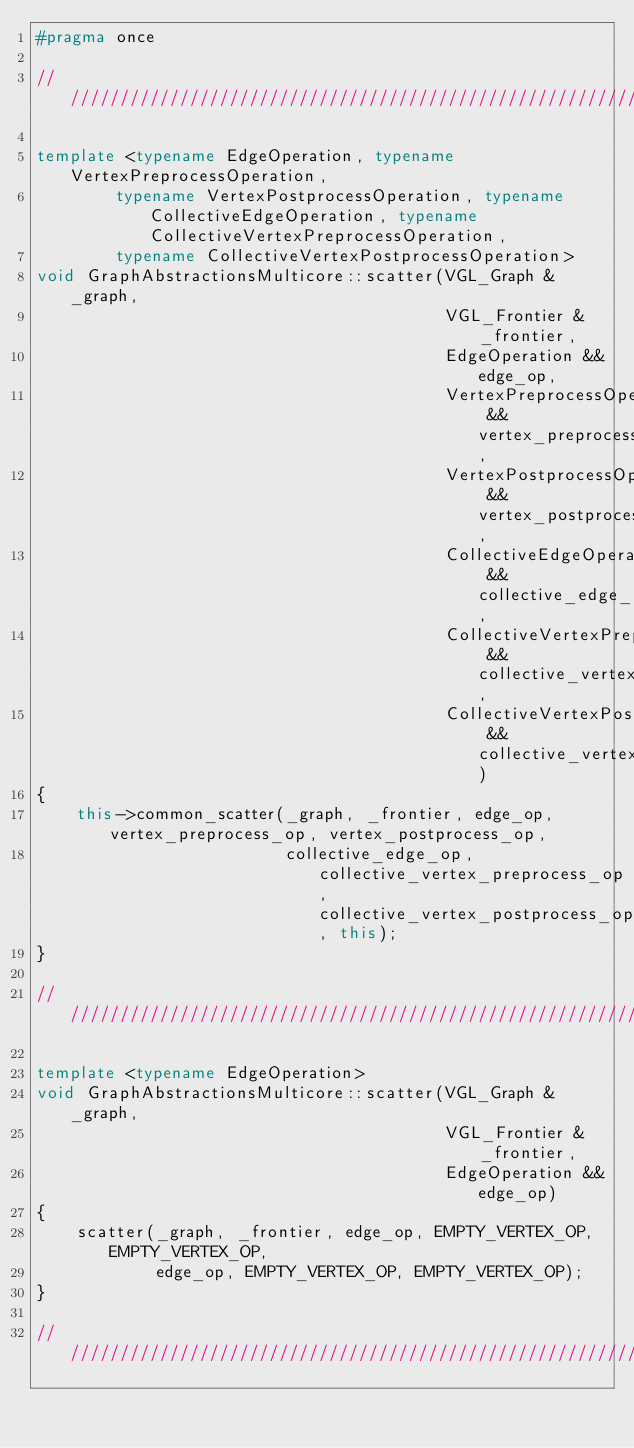Convert code to text. <code><loc_0><loc_0><loc_500><loc_500><_C++_>#pragma once

/////////////////////////////////////////////////////////////////////////////////////////////////////////////////////

template <typename EdgeOperation, typename VertexPreprocessOperation,
        typename VertexPostprocessOperation, typename CollectiveEdgeOperation, typename CollectiveVertexPreprocessOperation,
        typename CollectiveVertexPostprocessOperation>
void GraphAbstractionsMulticore::scatter(VGL_Graph &_graph,
                                         VGL_Frontier &_frontier,
                                         EdgeOperation &&edge_op,
                                         VertexPreprocessOperation &&vertex_preprocess_op,
                                         VertexPostprocessOperation &&vertex_postprocess_op,
                                         CollectiveEdgeOperation &&collective_edge_op,
                                         CollectiveVertexPreprocessOperation &&collective_vertex_preprocess_op,
                                         CollectiveVertexPostprocessOperation &&collective_vertex_postprocess_op)
{
    this->common_scatter(_graph, _frontier, edge_op, vertex_preprocess_op, vertex_postprocess_op,
                         collective_edge_op, collective_vertex_preprocess_op, collective_vertex_postprocess_op, this);
}

/////////////////////////////////////////////////////////////////////////////////////////////////////////////////////

template <typename EdgeOperation>
void GraphAbstractionsMulticore::scatter(VGL_Graph &_graph,
                                         VGL_Frontier &_frontier,
                                         EdgeOperation &&edge_op)
{
    scatter(_graph, _frontier, edge_op, EMPTY_VERTEX_OP, EMPTY_VERTEX_OP,
            edge_op, EMPTY_VERTEX_OP, EMPTY_VERTEX_OP);
}

/////////////////////////////////////////////////////////////////////////////////////////////////////////////////////
</code> 